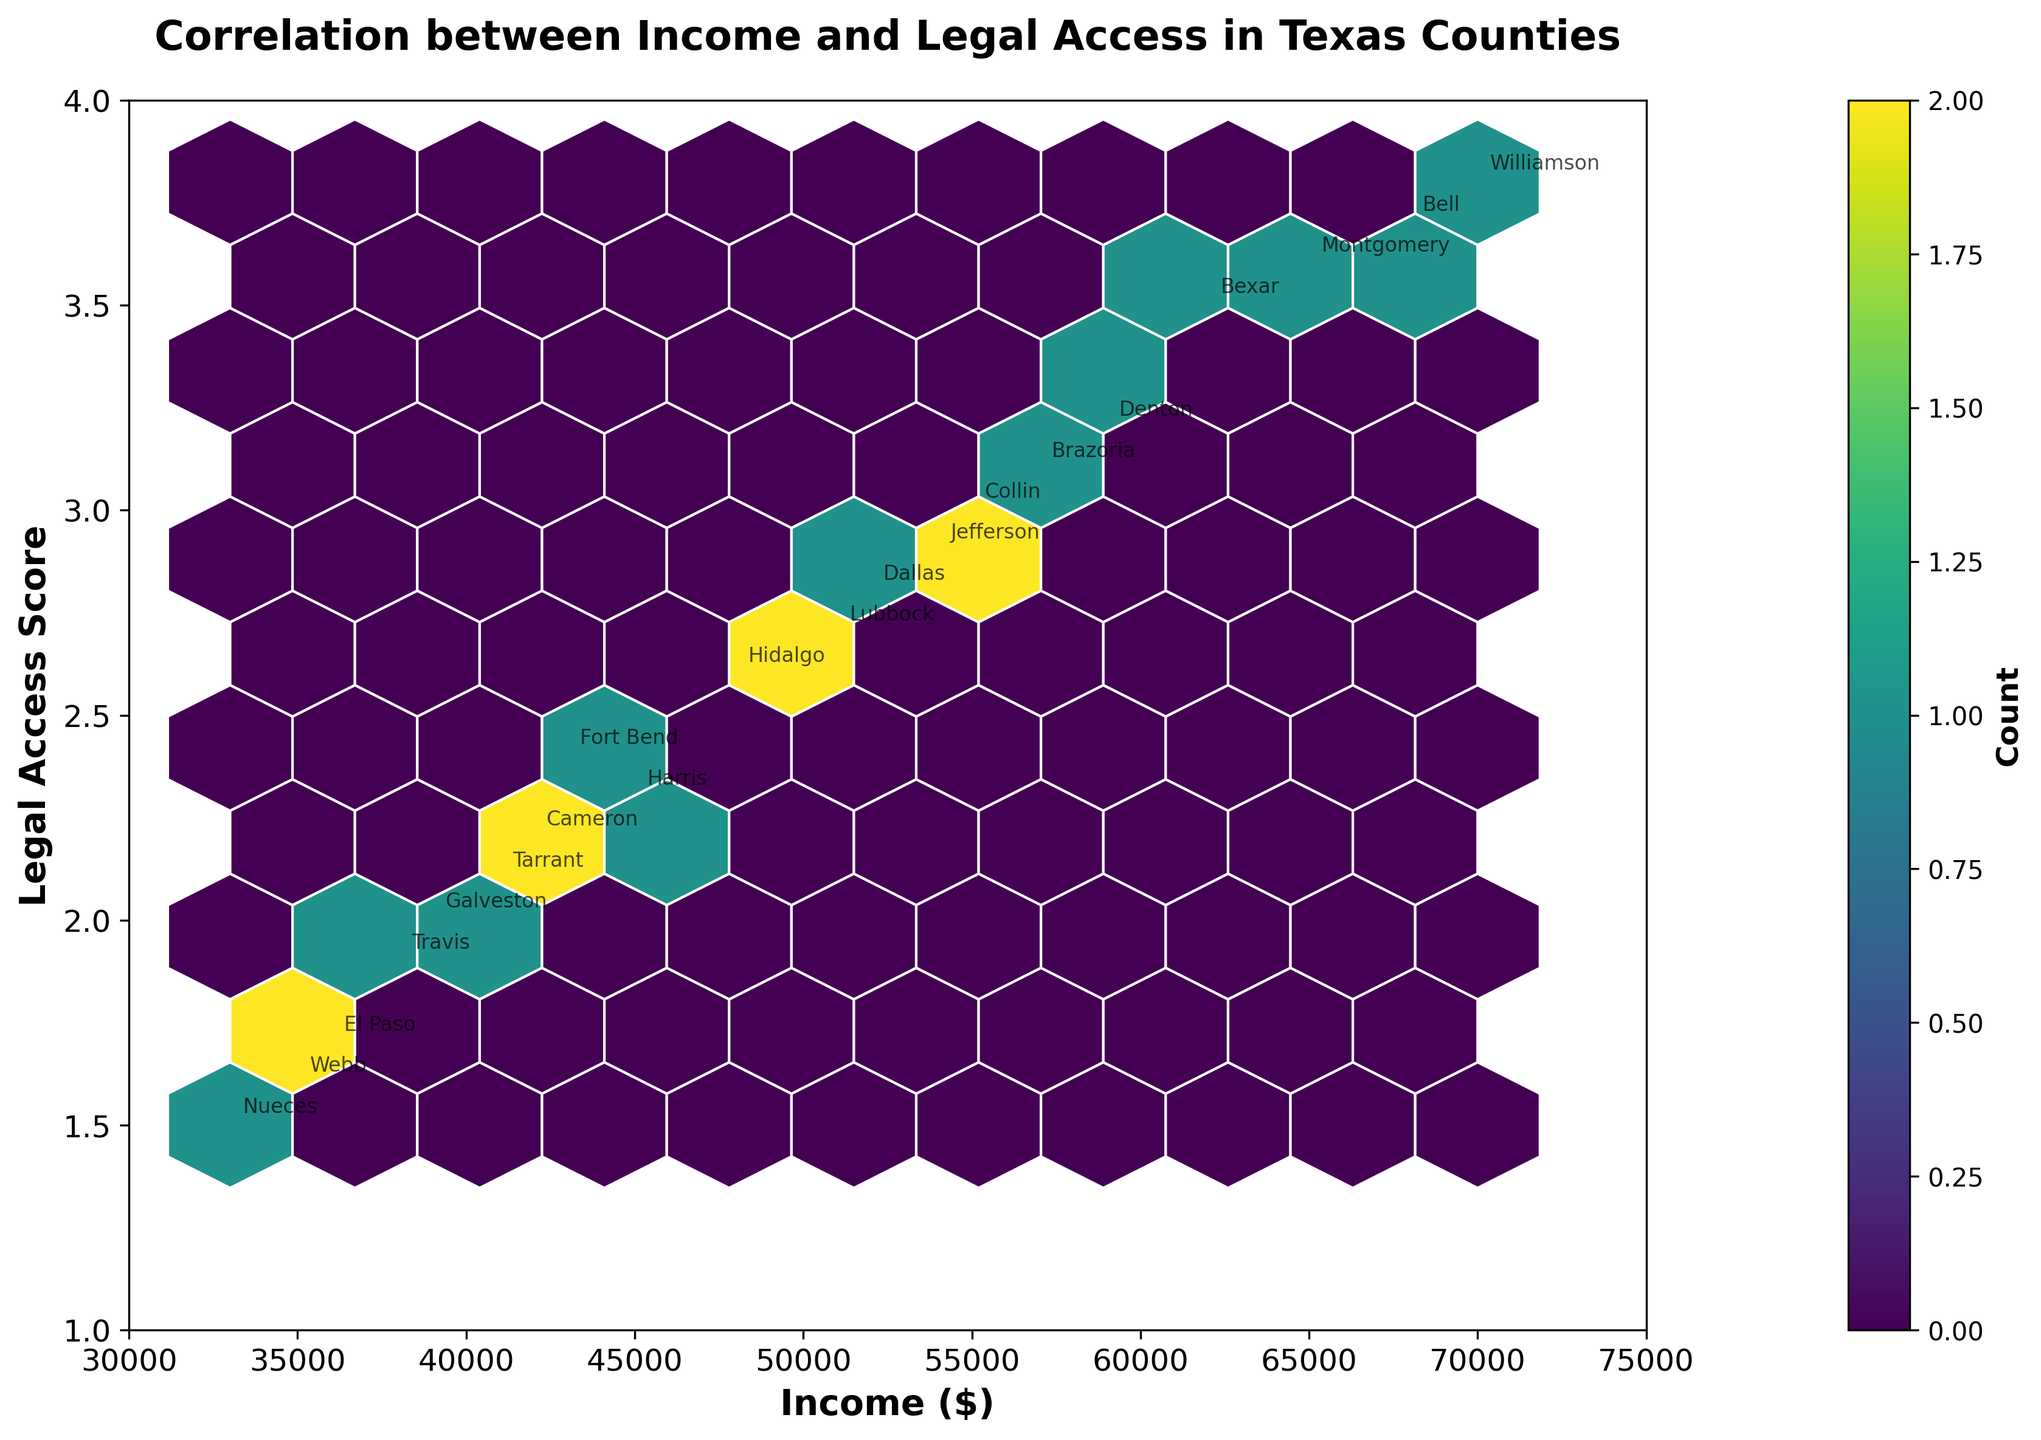What is the title of the plot? The title of the plot is located at the top center of the figure. It reads, "Correlation between Income and Legal Access in Texas Counties".
Answer: Correlation between Income and Legal Access in Texas Counties What are the labels on the X and Y axes? The labels on the X and Y axes are found below and to the left of the plot area, respectively. The X-axis label is "Income ($)" and the Y-axis label is "Legal Access Score".
Answer: Income ($), Legal Access Score How many color categories are used in the hexbin plot and what do they represent? The color categories in the hexbin plot are represented in a color gradient, typically showing intensity. In this plot, they range from light to dark shades, representing lower to higher counts of data points within each hexbin.
Answer: Multiple shades, representing counts By examining the hexbin plot, what can you say about the general trend between income levels and legal access scores? The hexbin plot shows that as income levels increase, the legal access scores tend to increase as well. This suggests a positive correlation between higher income levels and better access to legal representation.
Answer: Positive correlation Comparing Harris County to Montgomery County, which one has higher income and legal access score? By locating the points on the plot where Harris County and Montgomery County are annotated, Harris County's point appears at around $45,000 income and 2.3 legal access score, while Montgomery County's point is at $65,000 income and 3.6 legal access score. Thus, Montgomery County has higher values.
Answer: Montgomery County What is the range of the income values and the legal access scores shown on the axis? The X-axis for income ranges from $30,000 to $75,000, and the Y-axis for legal access scores ranges from 1 to 4. This information is taken directly from the axis limits.
Answer: $30,000 to $75,000; 1 to 4 Which county has the lowest legal access score, and what is its income level? By looking at the annotated points, Nueces County has the lowest legal access score of 1.5, with an income of $33,000. This point stands out as being the lowest on the Y-axis.
Answer: Nueces County, $33,000 What can you infer about the concentration of counties regarding their income and legal access scores? The darker regions in the hexbin plot indicate higher concentrations of data points. These darker hexagons appear around the mid-to-upper ranges of income levels (between $45,000 and $65,000) and legal access scores (between 2.3 and 3.6). This suggests a higher number of counties falling within these ranges.
Answer: Higher concentration around $45,000-$65,000 income, 2.3-3.6 legal access Which county has the highest income level, and what is its legal access score? Based on the annotations, Williamson County has the highest income level of $70,000 with a legal access score of 3.8. This point is located near the rightmost edge of the X-axis.
Answer: Williamson County, 3.8 What does the color bar represent and what is its label? The color bar, located next to the plot, represents the count of data points within each hexbin. The label on the color bar reads "Count". This helps interpret the density of data points in the plot.
Answer: Count 